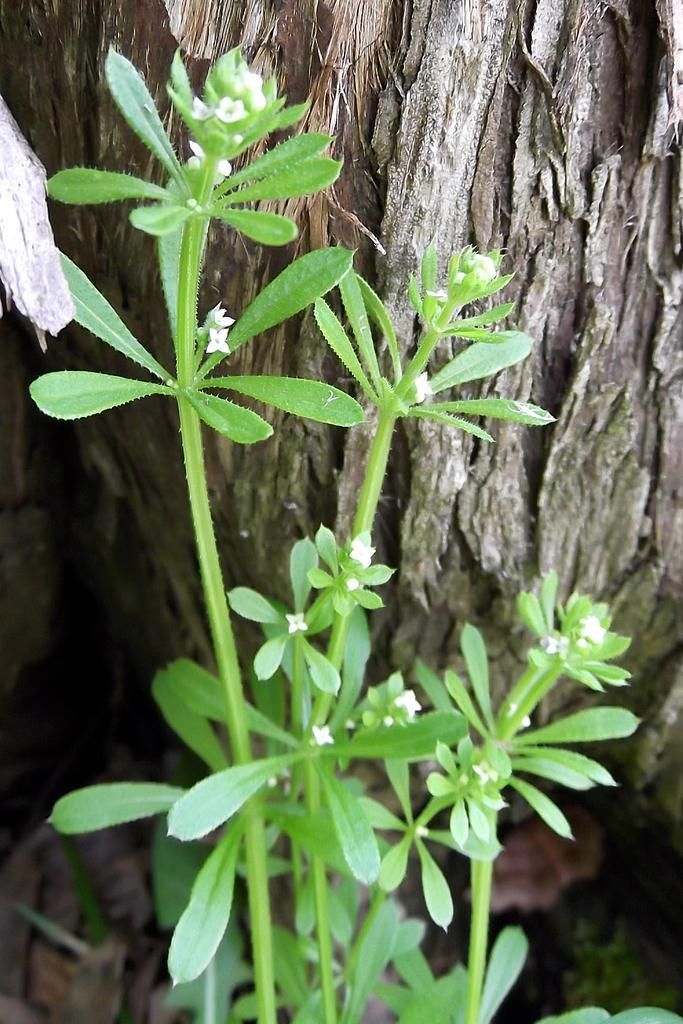Can you describe this image briefly? In this picture there is a white color small flowers plant in the front. Behind there is a tree trunk. 